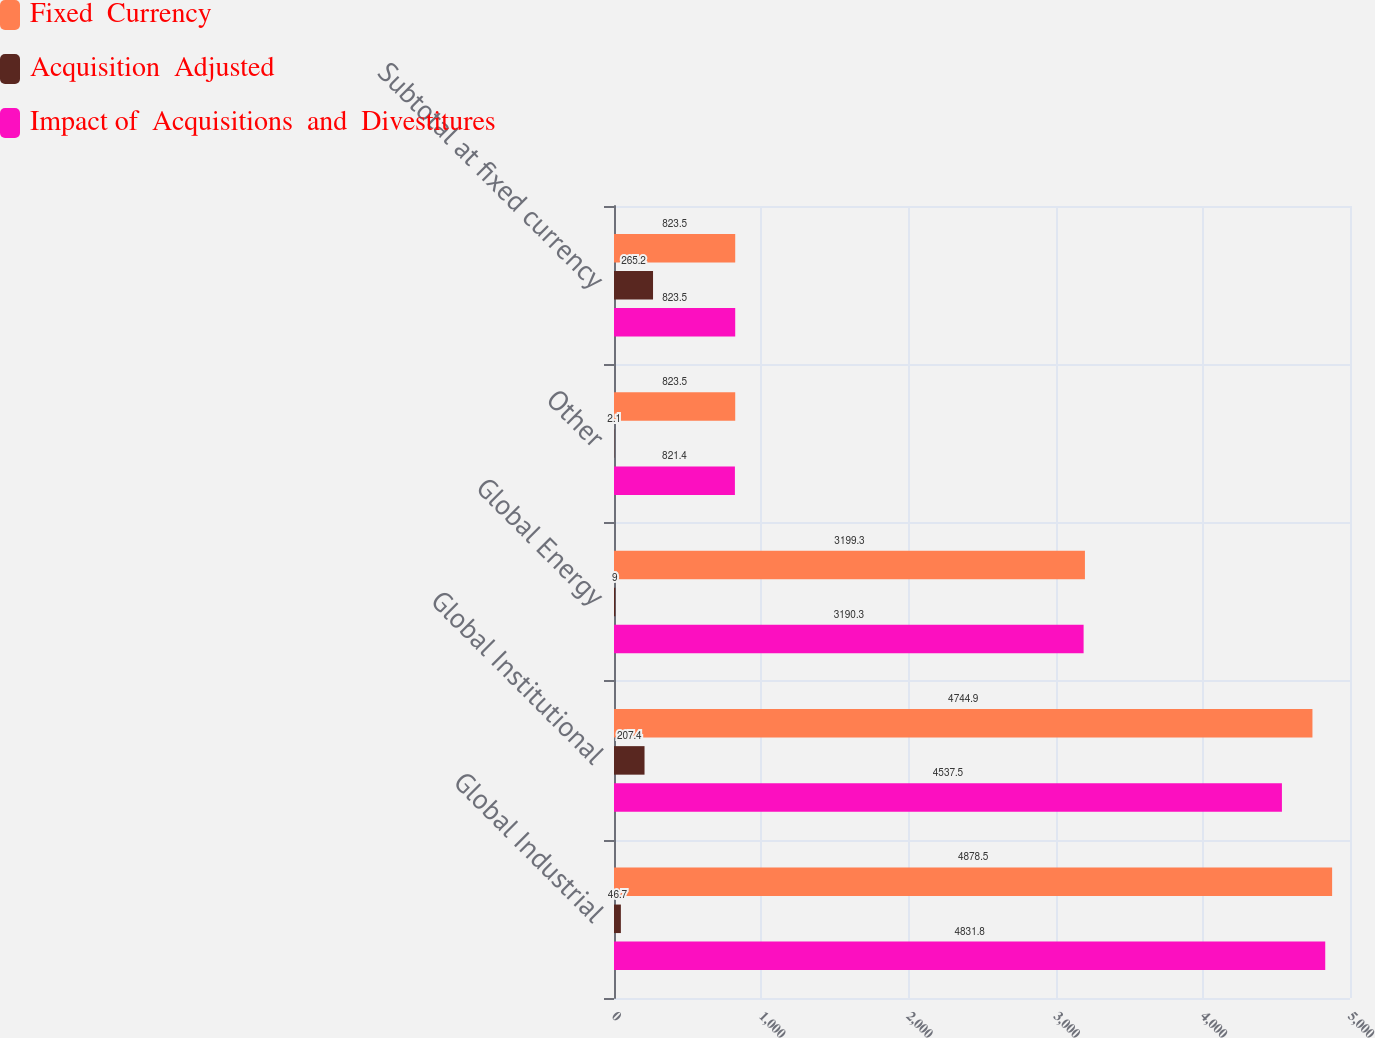Convert chart to OTSL. <chart><loc_0><loc_0><loc_500><loc_500><stacked_bar_chart><ecel><fcel>Global Industrial<fcel>Global Institutional<fcel>Global Energy<fcel>Other<fcel>Subtotal at fixed currency<nl><fcel>Fixed  Currency<fcel>4878.5<fcel>4744.9<fcel>3199.3<fcel>823.5<fcel>823.5<nl><fcel>Acquisition  Adjusted<fcel>46.7<fcel>207.4<fcel>9<fcel>2.1<fcel>265.2<nl><fcel>Impact of  Acquisitions  and  Divestitures<fcel>4831.8<fcel>4537.5<fcel>3190.3<fcel>821.4<fcel>823.5<nl></chart> 